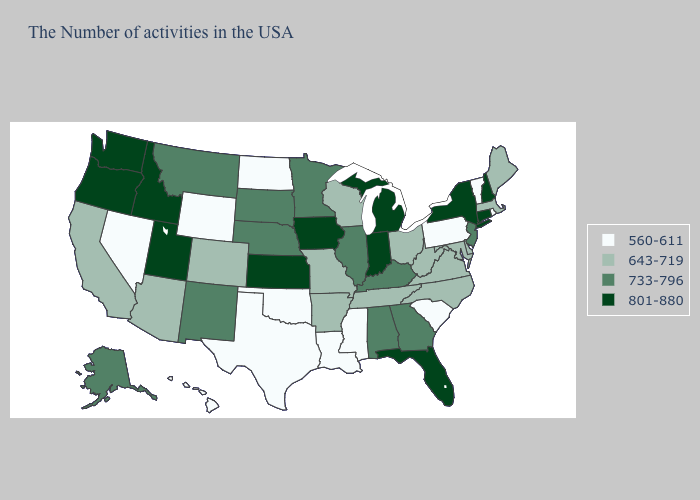What is the value of Oklahoma?
Short answer required. 560-611. Does Texas have the highest value in the USA?
Keep it brief. No. What is the value of Kansas?
Give a very brief answer. 801-880. Does Connecticut have the highest value in the Northeast?
Answer briefly. Yes. What is the value of Connecticut?
Give a very brief answer. 801-880. What is the highest value in the USA?
Answer briefly. 801-880. What is the value of Florida?
Quick response, please. 801-880. Is the legend a continuous bar?
Write a very short answer. No. Does Tennessee have a lower value than New Mexico?
Quick response, please. Yes. What is the value of Colorado?
Answer briefly. 643-719. Which states have the lowest value in the South?
Give a very brief answer. South Carolina, Mississippi, Louisiana, Oklahoma, Texas. Name the states that have a value in the range 733-796?
Quick response, please. New Jersey, Georgia, Kentucky, Alabama, Illinois, Minnesota, Nebraska, South Dakota, New Mexico, Montana, Alaska. What is the lowest value in the USA?
Short answer required. 560-611. Name the states that have a value in the range 560-611?
Give a very brief answer. Rhode Island, Vermont, Pennsylvania, South Carolina, Mississippi, Louisiana, Oklahoma, Texas, North Dakota, Wyoming, Nevada, Hawaii. Among the states that border Wyoming , which have the lowest value?
Give a very brief answer. Colorado. 